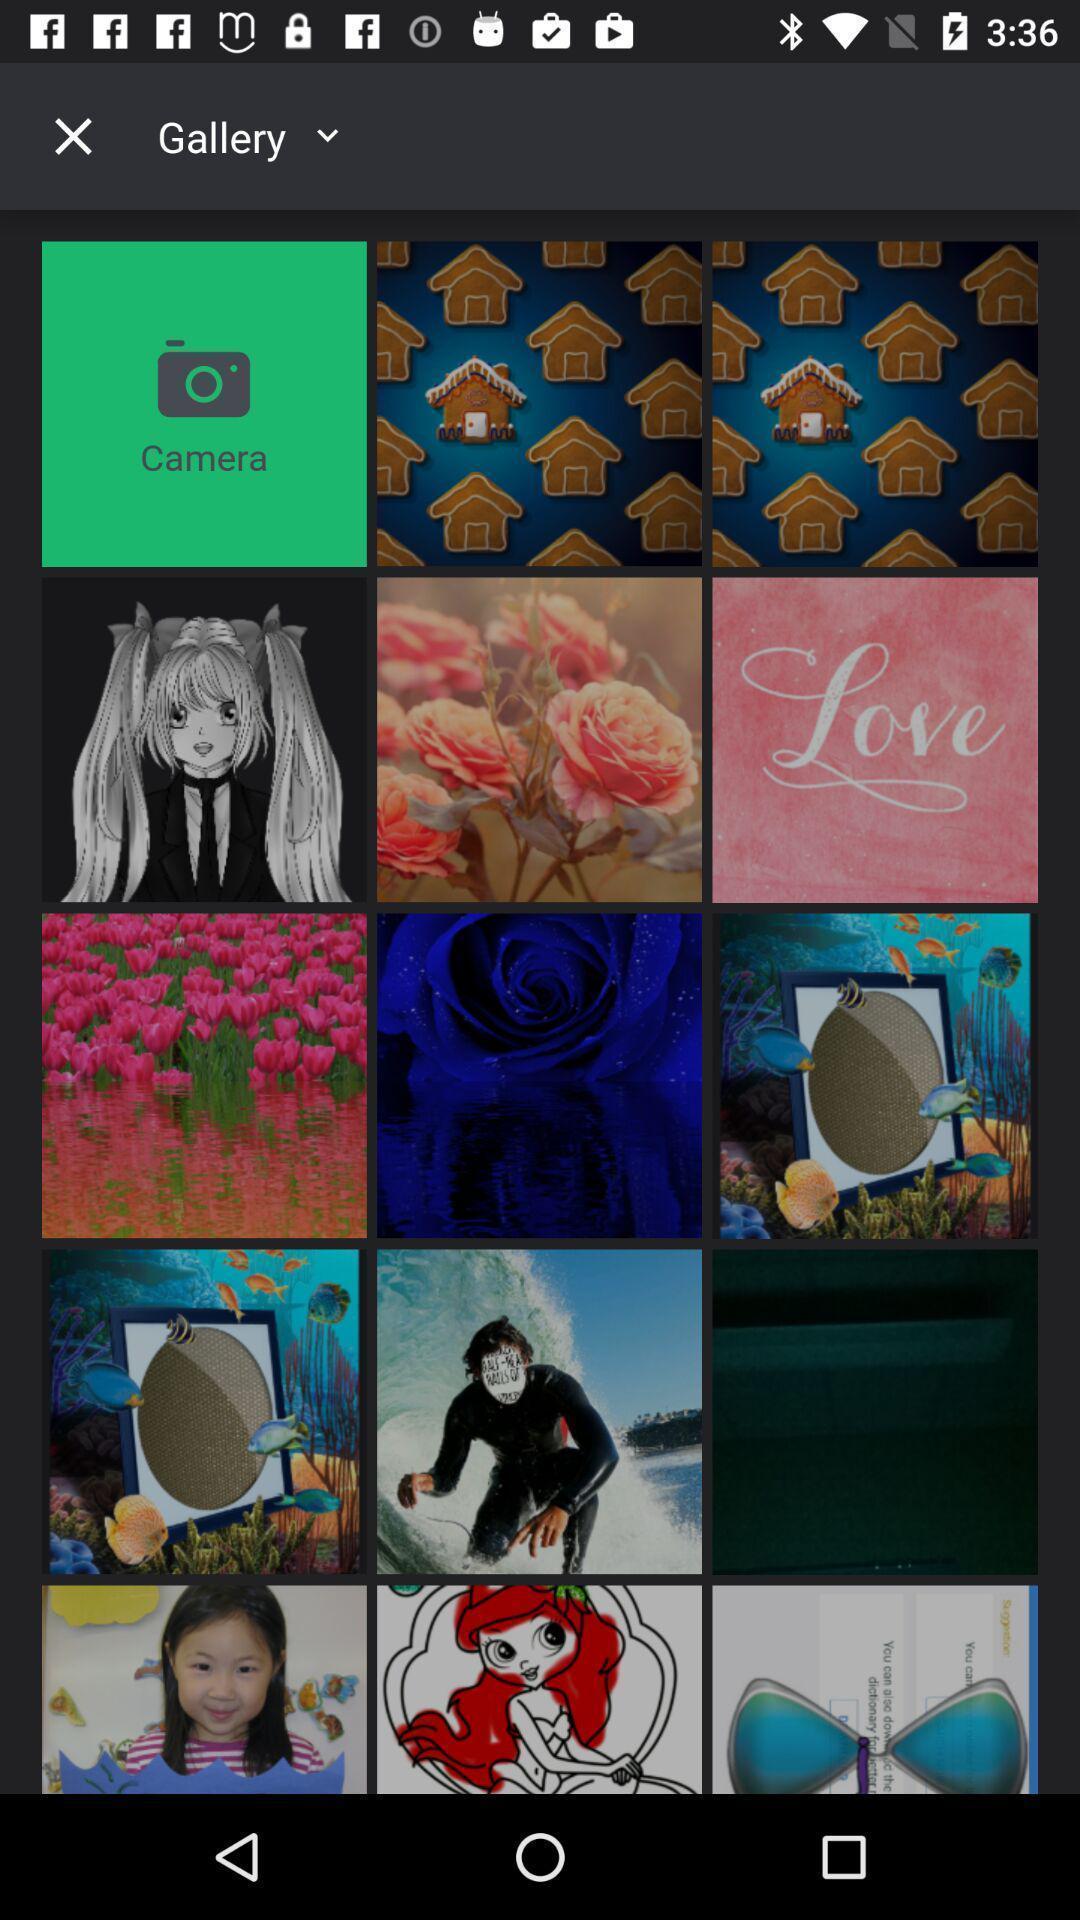Tell me what you see in this picture. Page that displaying various images. 